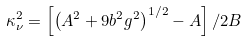Convert formula to latex. <formula><loc_0><loc_0><loc_500><loc_500>\kappa ^ { 2 } _ { \nu } = \left [ \left ( A ^ { 2 } + 9 b ^ { 2 } g ^ { 2 } \right ) ^ { 1 / 2 } - A \right ] / 2 B</formula> 